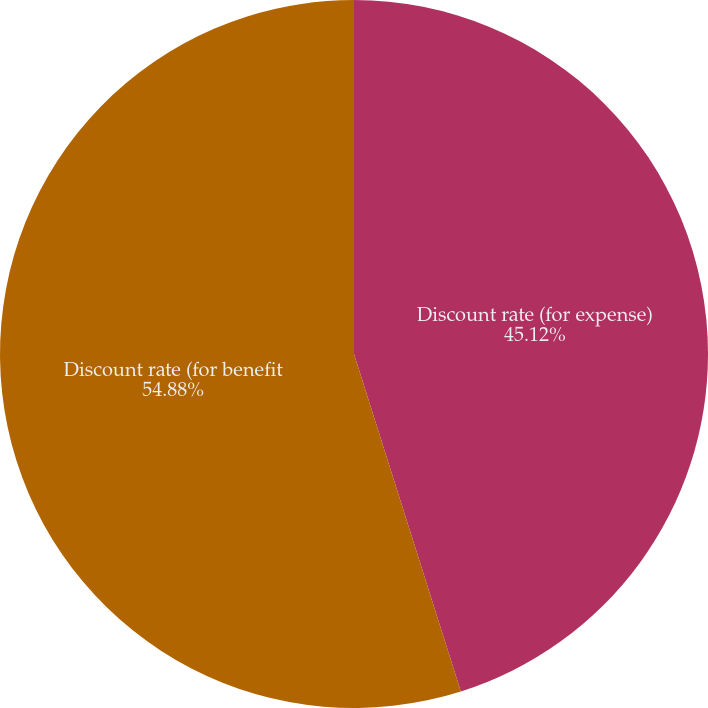<chart> <loc_0><loc_0><loc_500><loc_500><pie_chart><fcel>Discount rate (for expense)<fcel>Discount rate (for benefit<nl><fcel>45.12%<fcel>54.88%<nl></chart> 